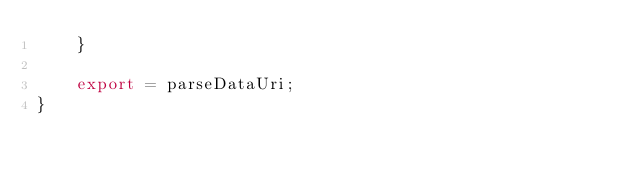Convert code to text. <code><loc_0><loc_0><loc_500><loc_500><_TypeScript_>    }

    export = parseDataUri;
}
</code> 